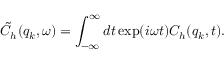<formula> <loc_0><loc_0><loc_500><loc_500>\tilde { C } _ { h } ( q _ { k } , \omega ) = \int _ { - \infty } ^ { \infty } d t \exp ( i \omega t ) C _ { h } ( q _ { k } , t ) .</formula> 